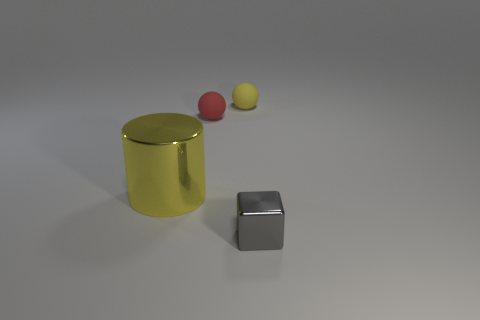Add 4 big gray balls. How many objects exist? 8 Subtract all cylinders. How many objects are left? 3 Subtract 0 cyan balls. How many objects are left? 4 Subtract all blue rubber cylinders. Subtract all yellow shiny things. How many objects are left? 3 Add 3 metal cylinders. How many metal cylinders are left? 4 Add 2 blue matte balls. How many blue matte balls exist? 2 